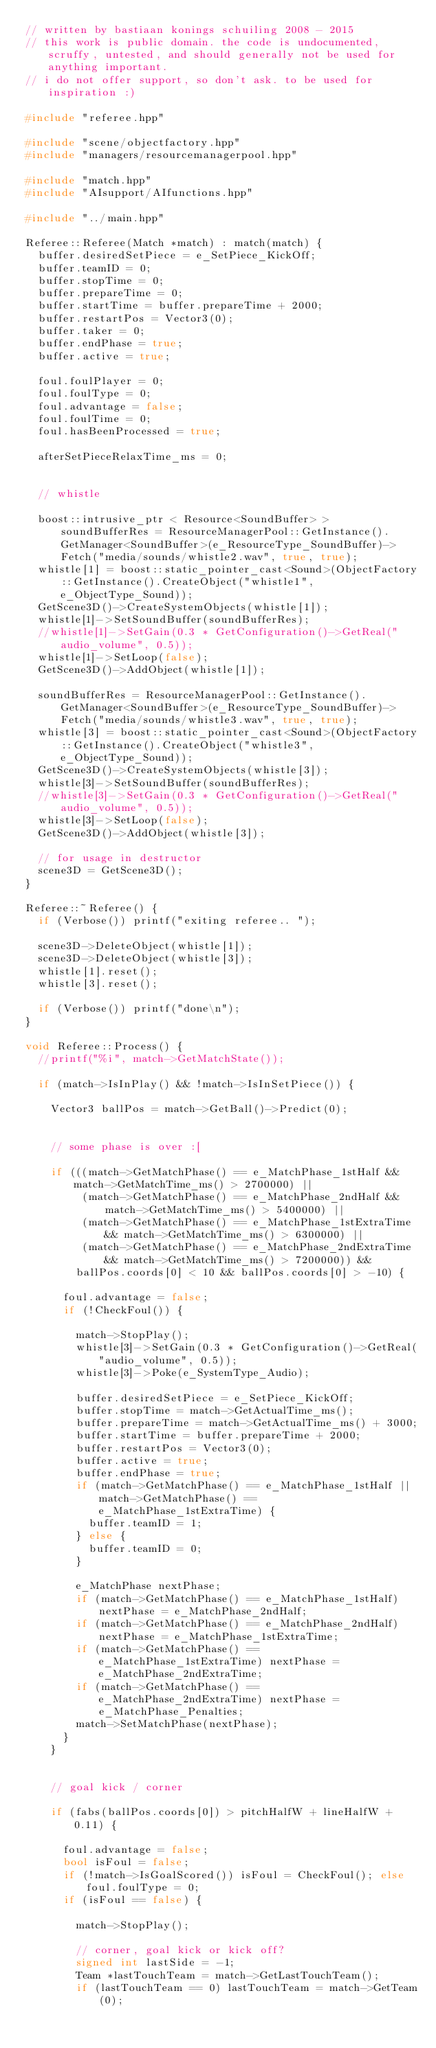Convert code to text. <code><loc_0><loc_0><loc_500><loc_500><_C++_>// written by bastiaan konings schuiling 2008 - 2015
// this work is public domain. the code is undocumented, scruffy, untested, and should generally not be used for anything important.
// i do not offer support, so don't ask. to be used for inspiration :)

#include "referee.hpp"

#include "scene/objectfactory.hpp"
#include "managers/resourcemanagerpool.hpp"

#include "match.hpp"
#include "AIsupport/AIfunctions.hpp"

#include "../main.hpp"

Referee::Referee(Match *match) : match(match) {
  buffer.desiredSetPiece = e_SetPiece_KickOff;
  buffer.teamID = 0;
  buffer.stopTime = 0;
  buffer.prepareTime = 0;
  buffer.startTime = buffer.prepareTime + 2000;
  buffer.restartPos = Vector3(0);
  buffer.taker = 0;
  buffer.endPhase = true;
  buffer.active = true;

  foul.foulPlayer = 0;
  foul.foulType = 0;
  foul.advantage = false;
  foul.foulTime = 0;
  foul.hasBeenProcessed = true;

  afterSetPieceRelaxTime_ms = 0;


  // whistle

  boost::intrusive_ptr < Resource<SoundBuffer> > soundBufferRes = ResourceManagerPool::GetInstance().GetManager<SoundBuffer>(e_ResourceType_SoundBuffer)->Fetch("media/sounds/whistle2.wav", true, true);
  whistle[1] = boost::static_pointer_cast<Sound>(ObjectFactory::GetInstance().CreateObject("whistle1", e_ObjectType_Sound));
  GetScene3D()->CreateSystemObjects(whistle[1]);
  whistle[1]->SetSoundBuffer(soundBufferRes);
  //whistle[1]->SetGain(0.3 * GetConfiguration()->GetReal("audio_volume", 0.5));
  whistle[1]->SetLoop(false);
  GetScene3D()->AddObject(whistle[1]);

  soundBufferRes = ResourceManagerPool::GetInstance().GetManager<SoundBuffer>(e_ResourceType_SoundBuffer)->Fetch("media/sounds/whistle3.wav", true, true);
  whistle[3] = boost::static_pointer_cast<Sound>(ObjectFactory::GetInstance().CreateObject("whistle3", e_ObjectType_Sound));
  GetScene3D()->CreateSystemObjects(whistle[3]);
  whistle[3]->SetSoundBuffer(soundBufferRes);
  //whistle[3]->SetGain(0.3 * GetConfiguration()->GetReal("audio_volume", 0.5));
  whistle[3]->SetLoop(false);
  GetScene3D()->AddObject(whistle[3]);

  // for usage in destructor
  scene3D = GetScene3D();
}

Referee::~Referee() {
  if (Verbose()) printf("exiting referee.. ");

  scene3D->DeleteObject(whistle[1]);
  scene3D->DeleteObject(whistle[3]);
  whistle[1].reset();
  whistle[3].reset();

  if (Verbose()) printf("done\n");
}

void Referee::Process() {
  //printf("%i", match->GetMatchState());

  if (match->IsInPlay() && !match->IsInSetPiece()) {

    Vector3 ballPos = match->GetBall()->Predict(0);


    // some phase is over :[

    if (((match->GetMatchPhase() == e_MatchPhase_1stHalf && match->GetMatchTime_ms() > 2700000) ||
         (match->GetMatchPhase() == e_MatchPhase_2ndHalf && match->GetMatchTime_ms() > 5400000) ||
         (match->GetMatchPhase() == e_MatchPhase_1stExtraTime && match->GetMatchTime_ms() > 6300000) ||
         (match->GetMatchPhase() == e_MatchPhase_2ndExtraTime && match->GetMatchTime_ms() > 7200000)) &&
        ballPos.coords[0] < 10 && ballPos.coords[0] > -10) {

      foul.advantage = false;
      if (!CheckFoul()) {

        match->StopPlay();
        whistle[3]->SetGain(0.3 * GetConfiguration()->GetReal("audio_volume", 0.5));
        whistle[3]->Poke(e_SystemType_Audio);

        buffer.desiredSetPiece = e_SetPiece_KickOff;
        buffer.stopTime = match->GetActualTime_ms();
        buffer.prepareTime = match->GetActualTime_ms() + 3000;
        buffer.startTime = buffer.prepareTime + 2000;
        buffer.restartPos = Vector3(0);
        buffer.active = true;
        buffer.endPhase = true;
        if (match->GetMatchPhase() == e_MatchPhase_1stHalf || match->GetMatchPhase() == e_MatchPhase_1stExtraTime) {
          buffer.teamID = 1;
        } else {
          buffer.teamID = 0;
        }

        e_MatchPhase nextPhase;
        if (match->GetMatchPhase() == e_MatchPhase_1stHalf) nextPhase = e_MatchPhase_2ndHalf;
        if (match->GetMatchPhase() == e_MatchPhase_2ndHalf) nextPhase = e_MatchPhase_1stExtraTime;
        if (match->GetMatchPhase() == e_MatchPhase_1stExtraTime) nextPhase = e_MatchPhase_2ndExtraTime;
        if (match->GetMatchPhase() == e_MatchPhase_2ndExtraTime) nextPhase = e_MatchPhase_Penalties;
        match->SetMatchPhase(nextPhase);
      }
    }


    // goal kick / corner

    if (fabs(ballPos.coords[0]) > pitchHalfW + lineHalfW + 0.11) {

      foul.advantage = false;
      bool isFoul = false;
      if (!match->IsGoalScored()) isFoul = CheckFoul(); else foul.foulType = 0;
      if (isFoul == false) {

        match->StopPlay();

        // corner, goal kick or kick off?
        signed int lastSide = -1;
        Team *lastTouchTeam = match->GetLastTouchTeam();
        if (lastTouchTeam == 0) lastTouchTeam = match->GetTeam(0);</code> 